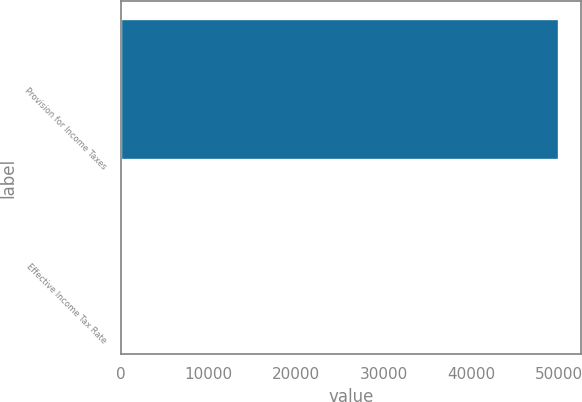Convert chart to OTSL. <chart><loc_0><loc_0><loc_500><loc_500><bar_chart><fcel>Provision for Income Taxes<fcel>Effective Income Tax Rate<nl><fcel>50036<fcel>16.8<nl></chart> 